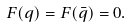<formula> <loc_0><loc_0><loc_500><loc_500>F ( q ) = F ( \bar { q } ) = 0 .</formula> 